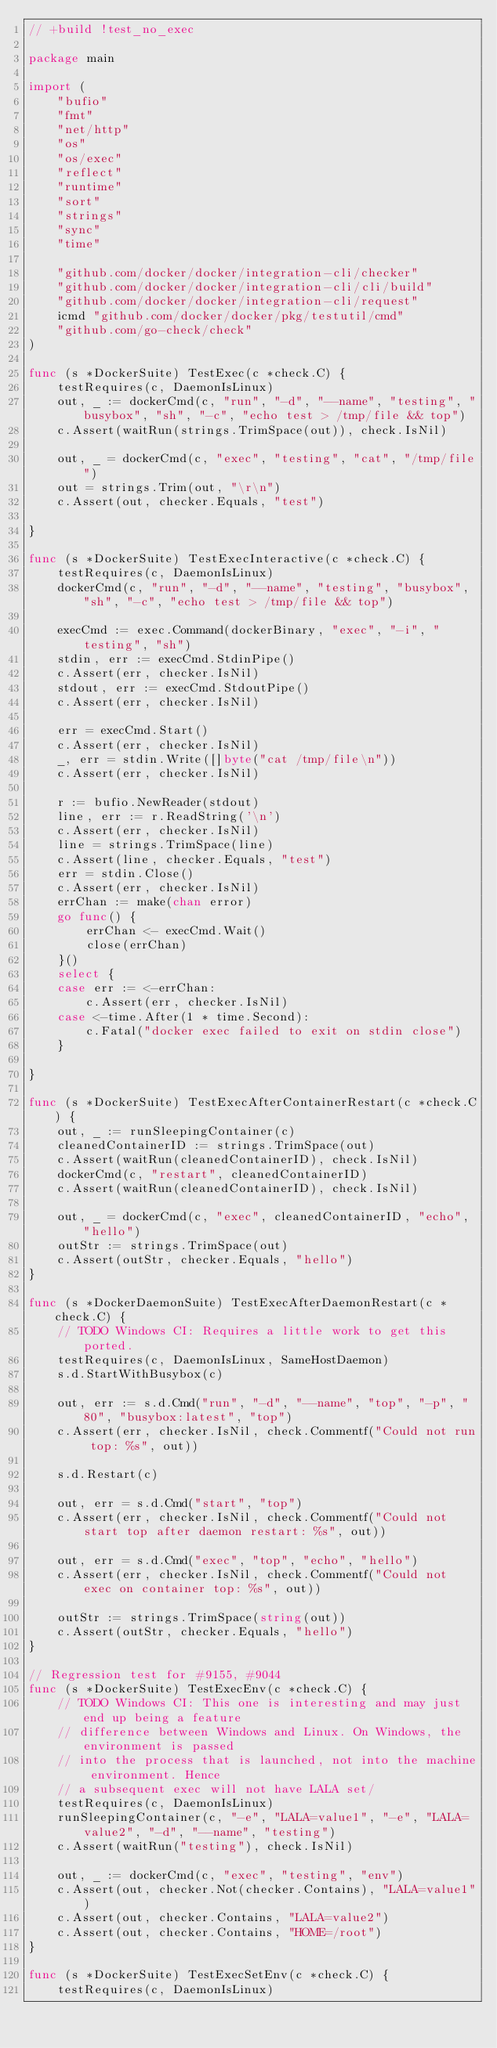<code> <loc_0><loc_0><loc_500><loc_500><_Go_>// +build !test_no_exec

package main

import (
	"bufio"
	"fmt"
	"net/http"
	"os"
	"os/exec"
	"reflect"
	"runtime"
	"sort"
	"strings"
	"sync"
	"time"

	"github.com/docker/docker/integration-cli/checker"
	"github.com/docker/docker/integration-cli/cli/build"
	"github.com/docker/docker/integration-cli/request"
	icmd "github.com/docker/docker/pkg/testutil/cmd"
	"github.com/go-check/check"
)

func (s *DockerSuite) TestExec(c *check.C) {
	testRequires(c, DaemonIsLinux)
	out, _ := dockerCmd(c, "run", "-d", "--name", "testing", "busybox", "sh", "-c", "echo test > /tmp/file && top")
	c.Assert(waitRun(strings.TrimSpace(out)), check.IsNil)

	out, _ = dockerCmd(c, "exec", "testing", "cat", "/tmp/file")
	out = strings.Trim(out, "\r\n")
	c.Assert(out, checker.Equals, "test")

}

func (s *DockerSuite) TestExecInteractive(c *check.C) {
	testRequires(c, DaemonIsLinux)
	dockerCmd(c, "run", "-d", "--name", "testing", "busybox", "sh", "-c", "echo test > /tmp/file && top")

	execCmd := exec.Command(dockerBinary, "exec", "-i", "testing", "sh")
	stdin, err := execCmd.StdinPipe()
	c.Assert(err, checker.IsNil)
	stdout, err := execCmd.StdoutPipe()
	c.Assert(err, checker.IsNil)

	err = execCmd.Start()
	c.Assert(err, checker.IsNil)
	_, err = stdin.Write([]byte("cat /tmp/file\n"))
	c.Assert(err, checker.IsNil)

	r := bufio.NewReader(stdout)
	line, err := r.ReadString('\n')
	c.Assert(err, checker.IsNil)
	line = strings.TrimSpace(line)
	c.Assert(line, checker.Equals, "test")
	err = stdin.Close()
	c.Assert(err, checker.IsNil)
	errChan := make(chan error)
	go func() {
		errChan <- execCmd.Wait()
		close(errChan)
	}()
	select {
	case err := <-errChan:
		c.Assert(err, checker.IsNil)
	case <-time.After(1 * time.Second):
		c.Fatal("docker exec failed to exit on stdin close")
	}

}

func (s *DockerSuite) TestExecAfterContainerRestart(c *check.C) {
	out, _ := runSleepingContainer(c)
	cleanedContainerID := strings.TrimSpace(out)
	c.Assert(waitRun(cleanedContainerID), check.IsNil)
	dockerCmd(c, "restart", cleanedContainerID)
	c.Assert(waitRun(cleanedContainerID), check.IsNil)

	out, _ = dockerCmd(c, "exec", cleanedContainerID, "echo", "hello")
	outStr := strings.TrimSpace(out)
	c.Assert(outStr, checker.Equals, "hello")
}

func (s *DockerDaemonSuite) TestExecAfterDaemonRestart(c *check.C) {
	// TODO Windows CI: Requires a little work to get this ported.
	testRequires(c, DaemonIsLinux, SameHostDaemon)
	s.d.StartWithBusybox(c)

	out, err := s.d.Cmd("run", "-d", "--name", "top", "-p", "80", "busybox:latest", "top")
	c.Assert(err, checker.IsNil, check.Commentf("Could not run top: %s", out))

	s.d.Restart(c)

	out, err = s.d.Cmd("start", "top")
	c.Assert(err, checker.IsNil, check.Commentf("Could not start top after daemon restart: %s", out))

	out, err = s.d.Cmd("exec", "top", "echo", "hello")
	c.Assert(err, checker.IsNil, check.Commentf("Could not exec on container top: %s", out))

	outStr := strings.TrimSpace(string(out))
	c.Assert(outStr, checker.Equals, "hello")
}

// Regression test for #9155, #9044
func (s *DockerSuite) TestExecEnv(c *check.C) {
	// TODO Windows CI: This one is interesting and may just end up being a feature
	// difference between Windows and Linux. On Windows, the environment is passed
	// into the process that is launched, not into the machine environment. Hence
	// a subsequent exec will not have LALA set/
	testRequires(c, DaemonIsLinux)
	runSleepingContainer(c, "-e", "LALA=value1", "-e", "LALA=value2", "-d", "--name", "testing")
	c.Assert(waitRun("testing"), check.IsNil)

	out, _ := dockerCmd(c, "exec", "testing", "env")
	c.Assert(out, checker.Not(checker.Contains), "LALA=value1")
	c.Assert(out, checker.Contains, "LALA=value2")
	c.Assert(out, checker.Contains, "HOME=/root")
}

func (s *DockerSuite) TestExecSetEnv(c *check.C) {
	testRequires(c, DaemonIsLinux)</code> 